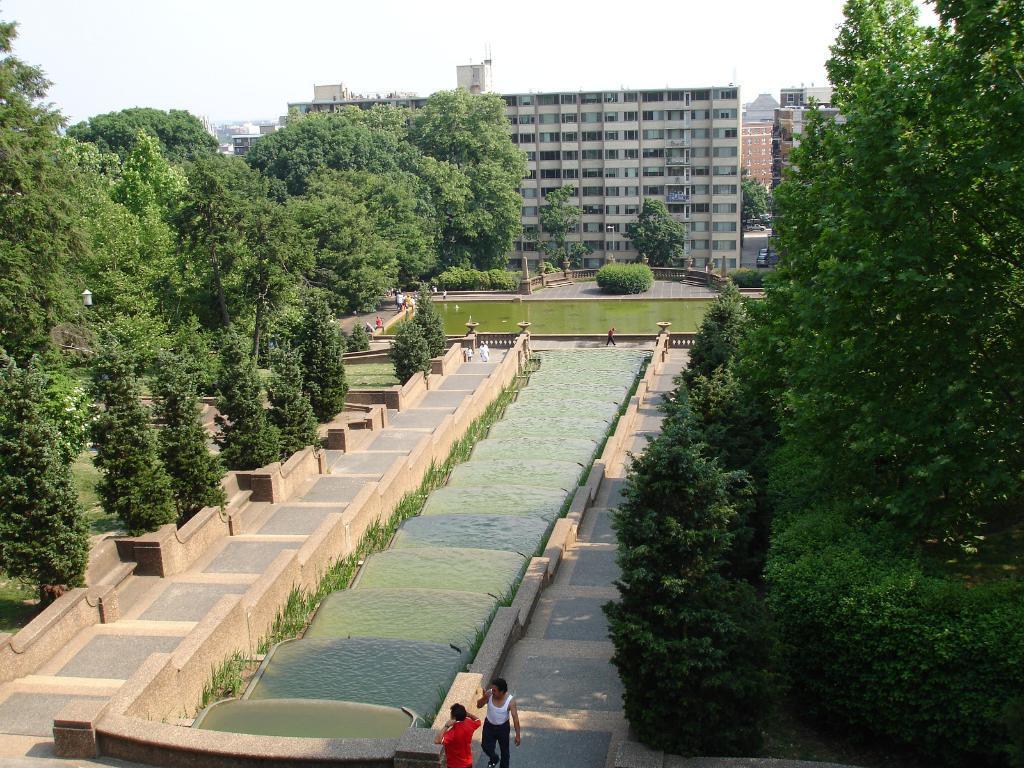Can you describe this image briefly? In this image we can see the trees, bushes, buildings and also some people. We can also see the grass and water in this image. At the top there is sky and at the bottom we can see the path. 